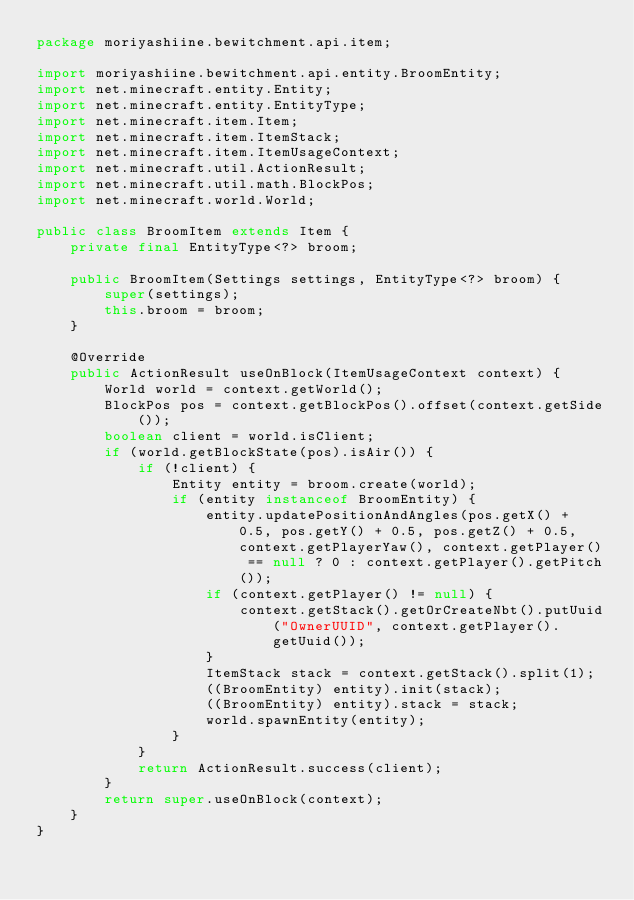<code> <loc_0><loc_0><loc_500><loc_500><_Java_>package moriyashiine.bewitchment.api.item;

import moriyashiine.bewitchment.api.entity.BroomEntity;
import net.minecraft.entity.Entity;
import net.minecraft.entity.EntityType;
import net.minecraft.item.Item;
import net.minecraft.item.ItemStack;
import net.minecraft.item.ItemUsageContext;
import net.minecraft.util.ActionResult;
import net.minecraft.util.math.BlockPos;
import net.minecraft.world.World;

public class BroomItem extends Item {
	private final EntityType<?> broom;
	
	public BroomItem(Settings settings, EntityType<?> broom) {
		super(settings);
		this.broom = broom;
	}
	
	@Override
	public ActionResult useOnBlock(ItemUsageContext context) {
		World world = context.getWorld();
		BlockPos pos = context.getBlockPos().offset(context.getSide());
		boolean client = world.isClient;
		if (world.getBlockState(pos).isAir()) {
			if (!client) {
				Entity entity = broom.create(world);
				if (entity instanceof BroomEntity) {
					entity.updatePositionAndAngles(pos.getX() + 0.5, pos.getY() + 0.5, pos.getZ() + 0.5, context.getPlayerYaw(), context.getPlayer() == null ? 0 : context.getPlayer().getPitch());
					if (context.getPlayer() != null) {
						context.getStack().getOrCreateNbt().putUuid("OwnerUUID", context.getPlayer().getUuid());
					}
					ItemStack stack = context.getStack().split(1);
					((BroomEntity) entity).init(stack);
					((BroomEntity) entity).stack = stack;
					world.spawnEntity(entity);
				}
			}
			return ActionResult.success(client);
		}
		return super.useOnBlock(context);
	}
}
</code> 